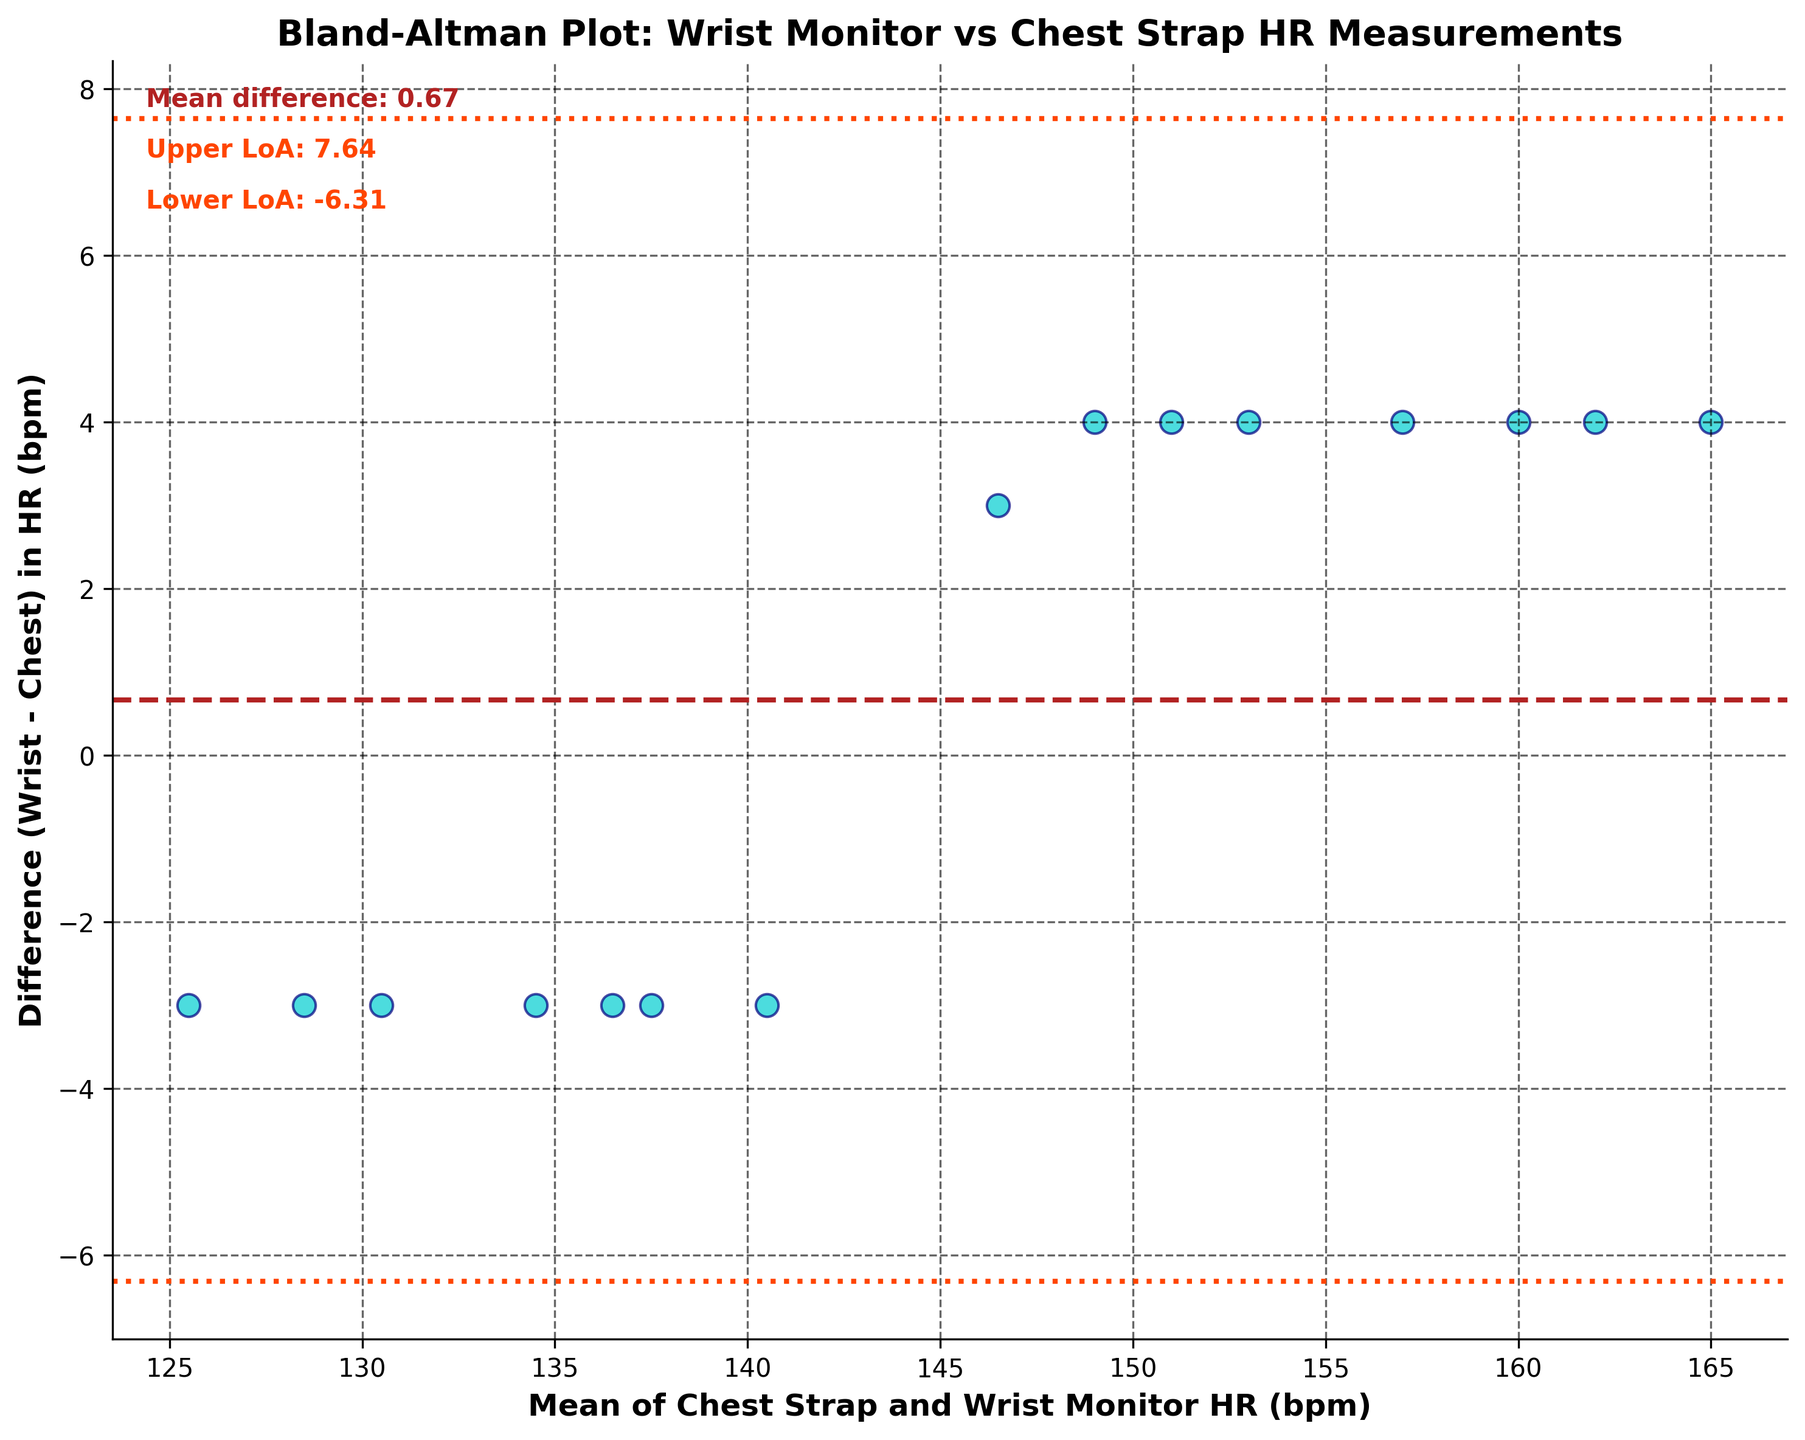How many dots (data points) are there on the plot? There are 15 rows in the provided data, each representing an athlete's heart rate measurements during training sessions, so there should be 15 dots on the plot.
Answer: 15 What's the title of the plot? The title is provided at the top of the plot, which is 'Bland-Altman Plot: Wrist Monitor vs Chest Strap HR Measurements'.
Answer: Bland-Altman Plot: Wrist Monitor vs Chest Strap HR Measurements What are the x-axis and y-axis labels in the plot? The x-axis is labeled 'Mean of Chest Strap and Wrist Monitor HR (bpm)', and the y-axis is labeled 'Difference (Wrist - Chest) in HR (bpm)'.
Answer: Mean of Chest Strap and Wrist Monitor HR (bpm); Difference (Wrist - Chest) in HR (bpm) What is the mean difference between the wrist and chest heart rate measurements? The mean difference is a horizontal line on the plot, labeled in the upper left corner. It states 'Mean difference: 2.67'.
Answer: 2.67 What are the upper and lower limits of agreement (LoA) shown in the plot? The limits of agreement are represented by the dashed lines around the mean difference, labeled on the top left as 'Upper LoA: 7.82' and 'Lower LoA: -2.47'.
Answer: Upper: 7.82; Lower: -2.47 Which data point (athlete) has the highest mean heart rate? To find the highest mean heart rate, look for the data point furthest to the right on the x-axis. This data point corresponds to Emre Sahin, whose mean heart rate is (163+167)/2 = 165 bpm.
Answer: Emre Sahin Is there any data point where the wrist monitor showed a lower heart rate than the chest strap? By checking points with negative differences on the y-axis, Zeynep Demir's data point shows a wrist heart rate lower than the chest strap (129 - 132 = -3 bpm).
Answer: Yes Which data point has the maximum positive difference in heart rate measurements (Wrist - Chest)? The data point with the highest position on the y-axis (maximum positive difference) corresponds to Emre Sahin with a difference of 4 bpm (167 - 163).
Answer: Emre Sahin What's the average of the mean heart rate values for all athletes? Sum the mean heart rate values for all athletes, which is [(145+148)/2 + ... + (147+151)/2] / 15. Using the data provided, compute this to obtain the average.
Answer: 142.5 Are there any outliers according to the limits of agreement, and if so, how many? An outlier would fall outside the limits of agreement. Since limits are -2.47 and 7.82, check if there's any point above 7.82 or below -2.47. From the plot, no data points fall outside these limits.
Answer: No 